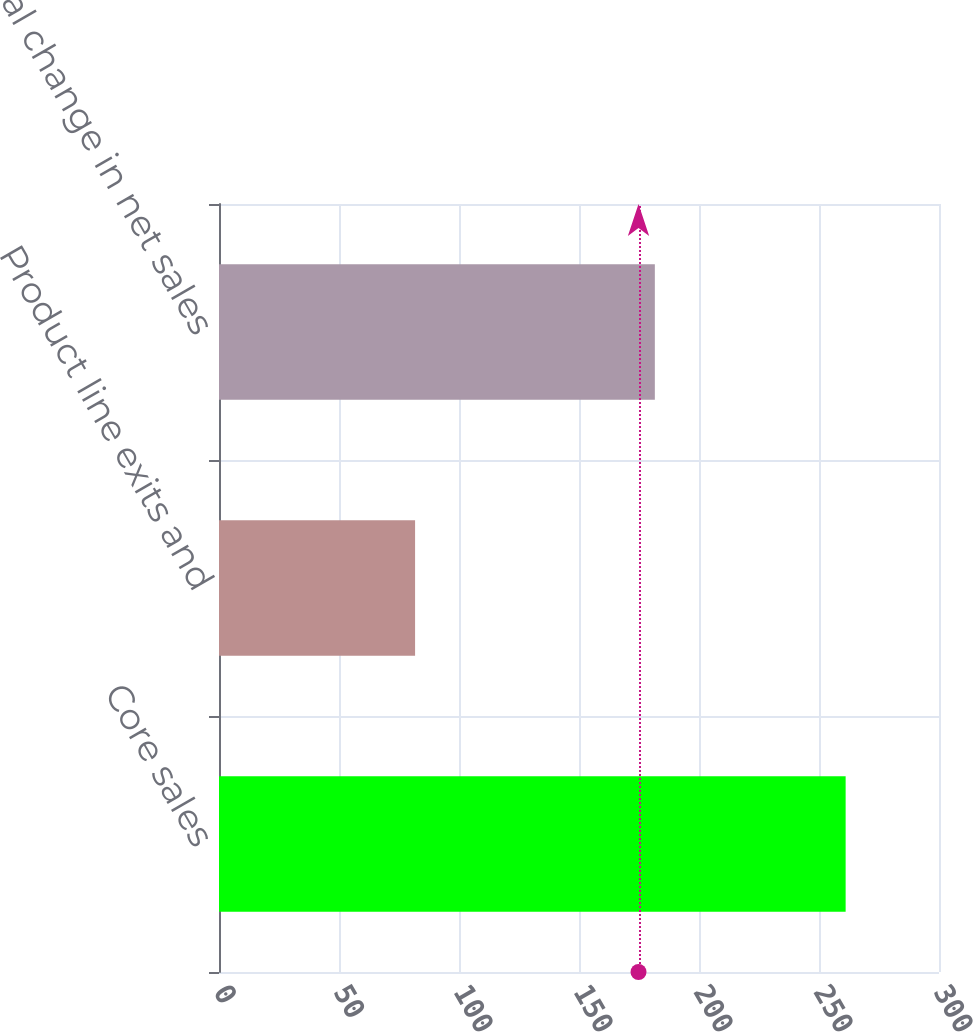Convert chart to OTSL. <chart><loc_0><loc_0><loc_500><loc_500><bar_chart><fcel>Core sales<fcel>Product line exits and<fcel>Total change in net sales<nl><fcel>261.1<fcel>81.7<fcel>181.6<nl></chart> 